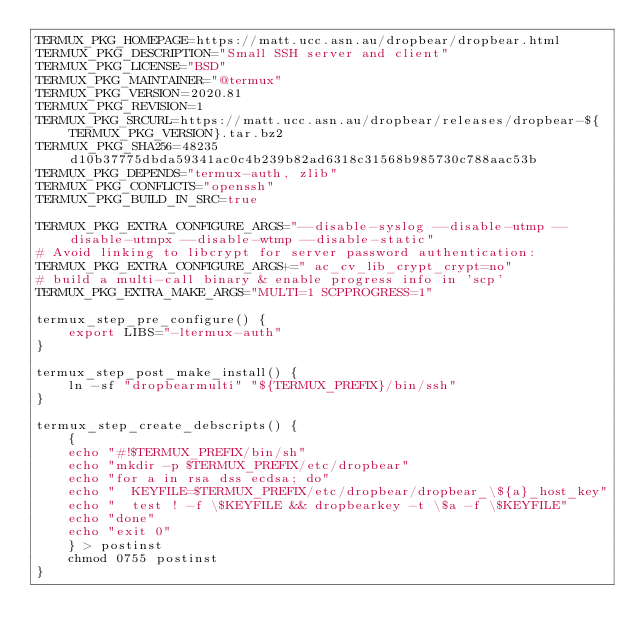<code> <loc_0><loc_0><loc_500><loc_500><_Bash_>TERMUX_PKG_HOMEPAGE=https://matt.ucc.asn.au/dropbear/dropbear.html
TERMUX_PKG_DESCRIPTION="Small SSH server and client"
TERMUX_PKG_LICENSE="BSD"
TERMUX_PKG_MAINTAINER="@termux"
TERMUX_PKG_VERSION=2020.81
TERMUX_PKG_REVISION=1
TERMUX_PKG_SRCURL=https://matt.ucc.asn.au/dropbear/releases/dropbear-${TERMUX_PKG_VERSION}.tar.bz2
TERMUX_PKG_SHA256=48235d10b37775dbda59341ac0c4b239b82ad6318c31568b985730c788aac53b
TERMUX_PKG_DEPENDS="termux-auth, zlib"
TERMUX_PKG_CONFLICTS="openssh"
TERMUX_PKG_BUILD_IN_SRC=true

TERMUX_PKG_EXTRA_CONFIGURE_ARGS="--disable-syslog --disable-utmp --disable-utmpx --disable-wtmp --disable-static"
# Avoid linking to libcrypt for server password authentication:
TERMUX_PKG_EXTRA_CONFIGURE_ARGS+=" ac_cv_lib_crypt_crypt=no"
# build a multi-call binary & enable progress info in 'scp'
TERMUX_PKG_EXTRA_MAKE_ARGS="MULTI=1 SCPPROGRESS=1"

termux_step_pre_configure() {
	export LIBS="-ltermux-auth"
}

termux_step_post_make_install() {
	ln -sf "dropbearmulti" "${TERMUX_PREFIX}/bin/ssh"
}

termux_step_create_debscripts() {
	{
	echo "#!$TERMUX_PREFIX/bin/sh"
	echo "mkdir -p $TERMUX_PREFIX/etc/dropbear"
	echo "for a in rsa dss ecdsa; do"
	echo "	KEYFILE=$TERMUX_PREFIX/etc/dropbear/dropbear_\${a}_host_key"
	echo "	test ! -f \$KEYFILE && dropbearkey -t \$a -f \$KEYFILE"
	echo "done"
	echo "exit 0"
	} > postinst
	chmod 0755 postinst
}

</code> 